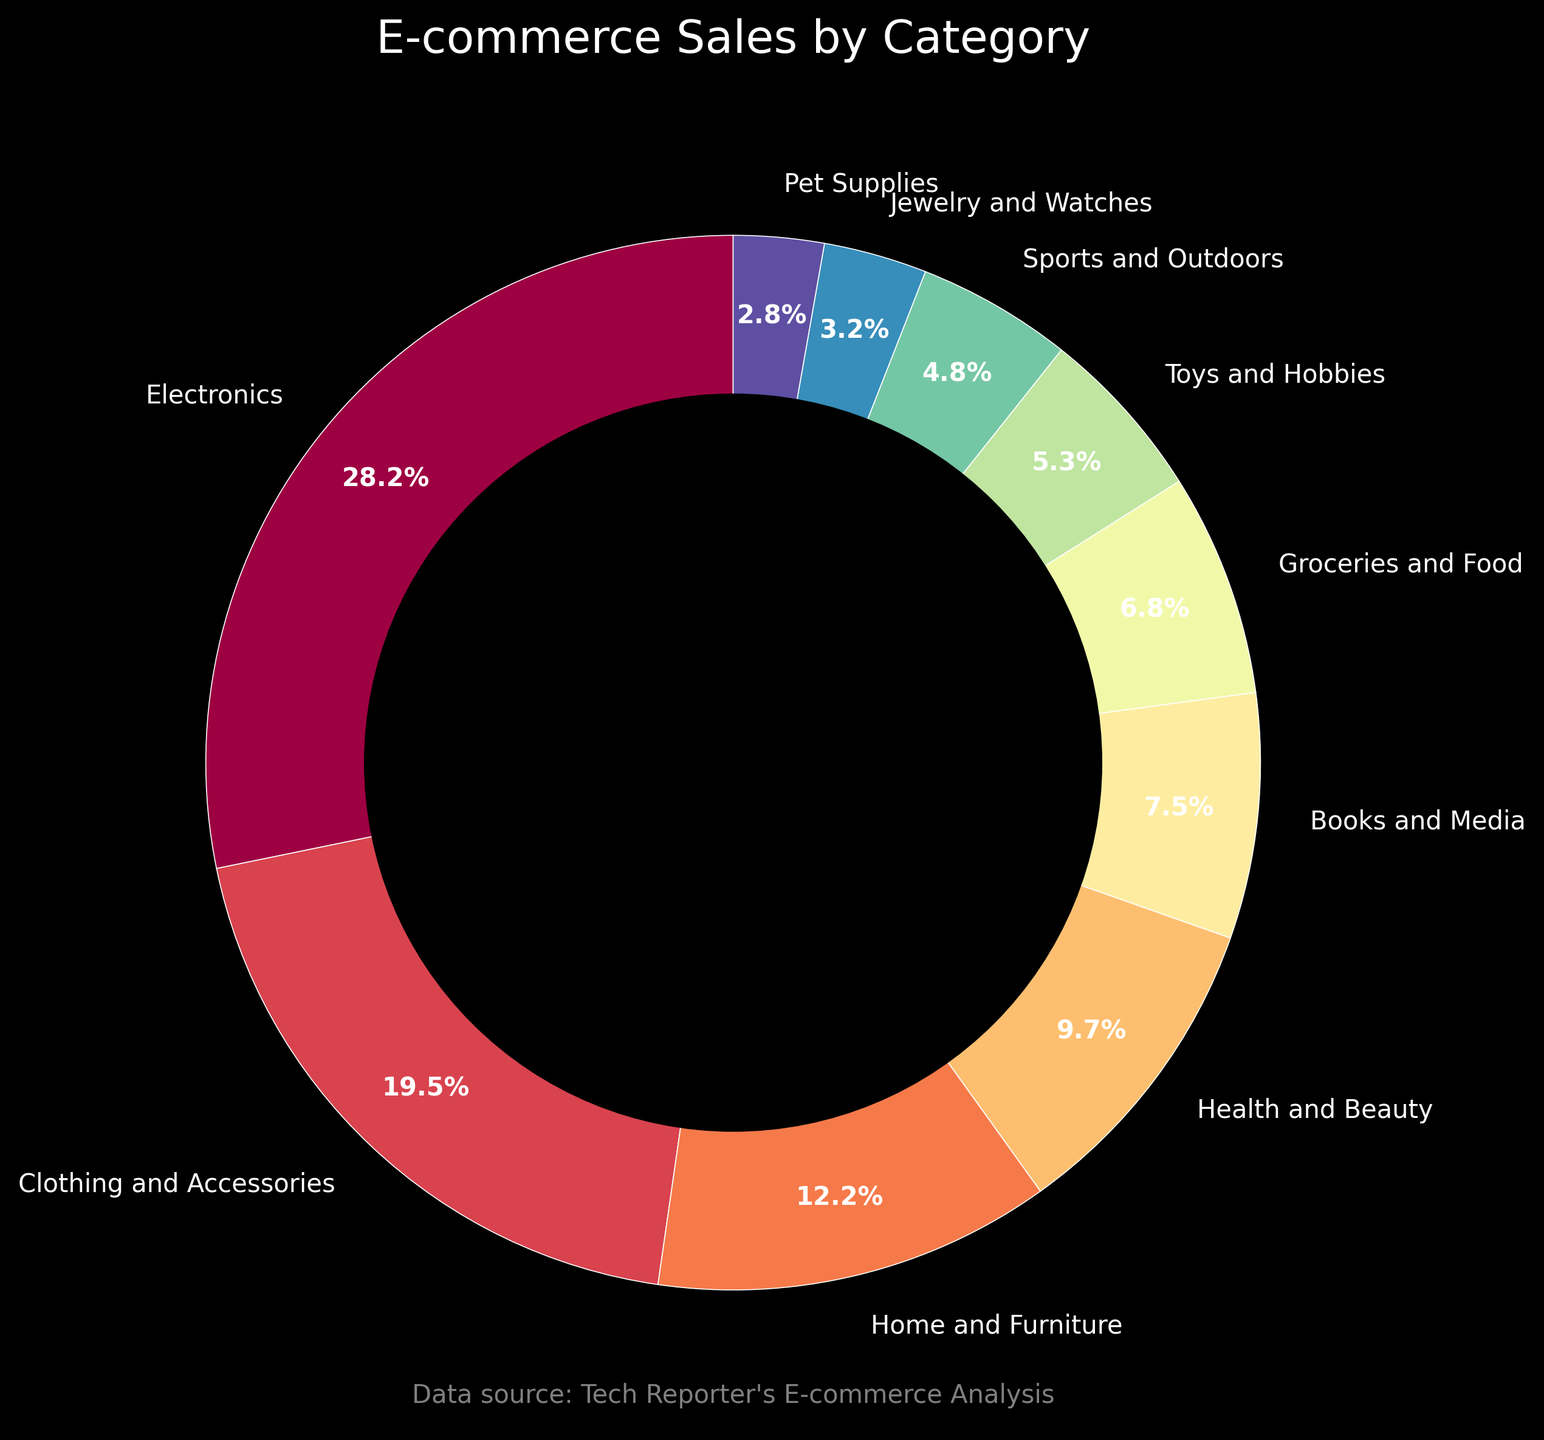What category has the highest percentage of total e-commerce sales? The wedge with the largest area and percentage label is "Electronics" with 28.5%.
Answer: Electronics Which category has a higher percentage of total sales: Clothing and Accessories or Home and Furniture? The wedges labeled "Clothing and Accessories" and "Home and Furniture" show that Clothing and Accessories (19.7%) is higher than Home and Furniture (12.3%).
Answer: Clothing and Accessories What is the combined percentage of Groceries and Food and Pet Supplies? The percentages for Groceries and Food (6.9%) and Pet Supplies (2.8%) summed together are 6.9% + 2.8% = 9.7%.
Answer: 9.7% How much higher is the percentage of Electronics compared to Books and Media? The percentage of Electronics is 28.5% and for Books and Media it is 7.6%. The difference is 28.5% - 7.6% = 20.9%.
Answer: 20.9% What categories have less than 5% of the total e-commerce sales? The wedges with labels showing percentages under 5% are "Sports and Outdoors" (4.8%), "Jewelry and Watches" (3.2%), and "Pet Supplies" (2.8%).
Answer: Sports and Outdoors, Jewelry and Watches, Pet Supplies Which category is visually represented with the green color? The category visually associated with the green color in the pie chart is "Clothing and Accessories."
Answer: Clothing and Accessories What is the sum percentage of the categories that are over 10%? The categories over 10% are Electronics (28.5%), Clothing and Accessories (19.7%), and Home and Furniture (12.3%). Their sum is 28.5% + 19.7% + 12.3% = 60.5%.
Answer: 60.5% Compare the total percentage of Health and Beauty to Toys and Hobbies. How much more or less is it? Health and Beauty is 9.8% while Toys and Hobbies is 5.4%. The difference is 9.8% - 5.4% = 4.4%.
Answer: 4.4% What percentage of sales does Categories other than the top two (Electronics and Clothing and Accessories) constitute? The top two percentages are Electronics (28.5%) and Clothing and Accessories (19.7%). Sum of the remaining categories is 100% - (28.5% + 19.7%) = 51.8%.
Answer: 51.8% 